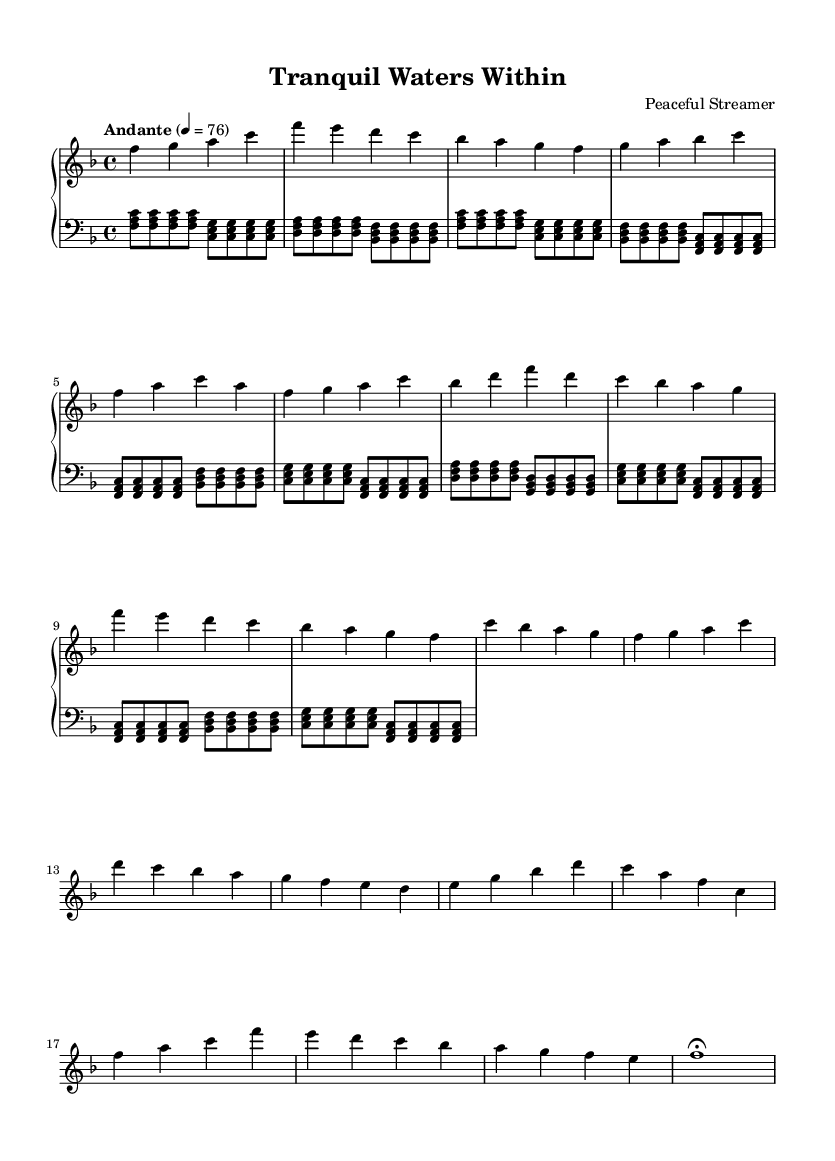What is the key signature of this music? The key signature shows one flat, indicating B♭ major or G minor. The presence of B♭ and other notes without flats suggests it is F major, the relative major of D minor.
Answer: F major What is the time signature of this piece? The time signature is shown at the beginning of the staff as a fraction, specifically 4/4, which means there are four beats in a measure and the quarter note gets the beat.
Answer: 4/4 What is the tempo marking of the music? The tempo marking appears at the beginning, stating "Andante" with a metronome marking of quarter note = 76, indicating a moderate pace.
Answer: Andante How many bars are in the verse section? By counting the measures indicated in the score, the verse section encompasses 4 bars, specified by the music notation starting from the first verse line until the end of the verse.
Answer: 4 What mood or feeling does this piece aim to convey? Analyzing the chord progressions and use of softer dynamics typically conveys peacefulness, and the gentle flowing melodies match the theme of inner tranquility found in romantic ballads. This reflects the serene emotional context.
Answer: Peacefulness What is the primary melodic theme found in the chorus? The chorus features a simple, repetitive melodic structure initiated in the right hand that often descends in pitch, providing a soothing character that aligns with the notion of finding inner peace repetitively.
Answer: Soothing character How does the bridge contrast with the rest of the piece? The bridge introduces different rhythmic patterns and shifts to a new melodic idea; this transition tends to create a sense of tension or movement before returning to the tranquil emotional state of the main theme, which could be a reflection of turmoil before achieving peace.
Answer: Introduction of tension 